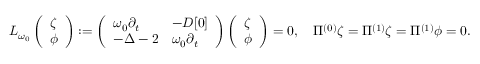Convert formula to latex. <formula><loc_0><loc_0><loc_500><loc_500>L _ { \omega _ { 0 } } \left ( \begin{array} { l } { \zeta } \\ { \phi } \end{array} \right ) \colon = \left ( \begin{array} { l l } { \omega _ { 0 } \partial _ { t } } & { - D [ 0 ] } \\ { - \Delta - 2 } & { \omega _ { 0 } \partial _ { t } } \end{array} \right ) \left ( \begin{array} { l } { \zeta } \\ { \phi } \end{array} \right ) = 0 , \quad \Pi ^ { ( 0 ) } \zeta = \Pi ^ { ( 1 ) } \zeta = \Pi ^ { ( 1 ) } \phi = 0 .</formula> 